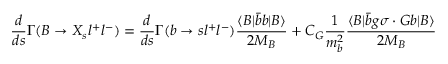Convert formula to latex. <formula><loc_0><loc_0><loc_500><loc_500>\frac { d } { d s } \Gamma ( B \to X _ { s } l ^ { + } l ^ { - } ) = \frac { d } { d s } \Gamma ( b \to s l ^ { + } l ^ { - } ) \frac { \langle B | \bar { b } b | B \rangle } { 2 M _ { B } } + C _ { G } \frac { 1 } { m _ { b } ^ { 2 } } \frac { \langle B | \bar { b } g \sigma \cdot G b | B \rangle } { 2 M _ { B } }</formula> 